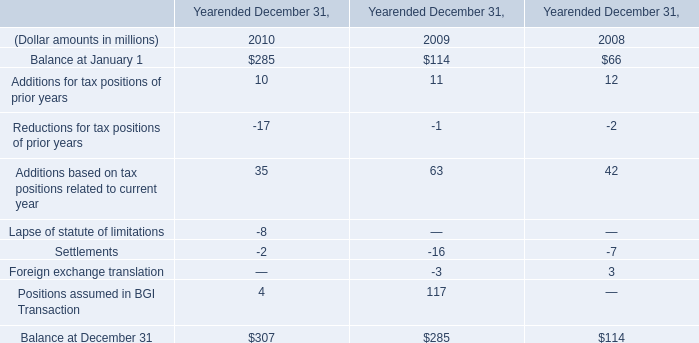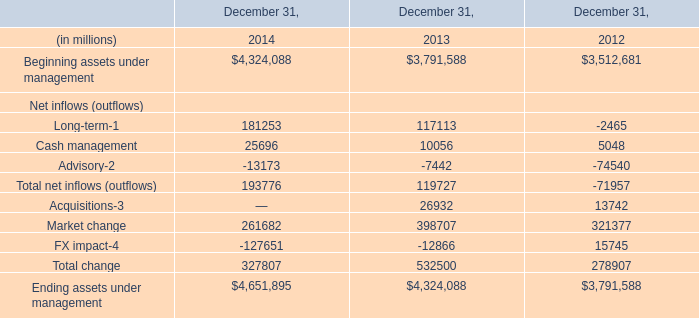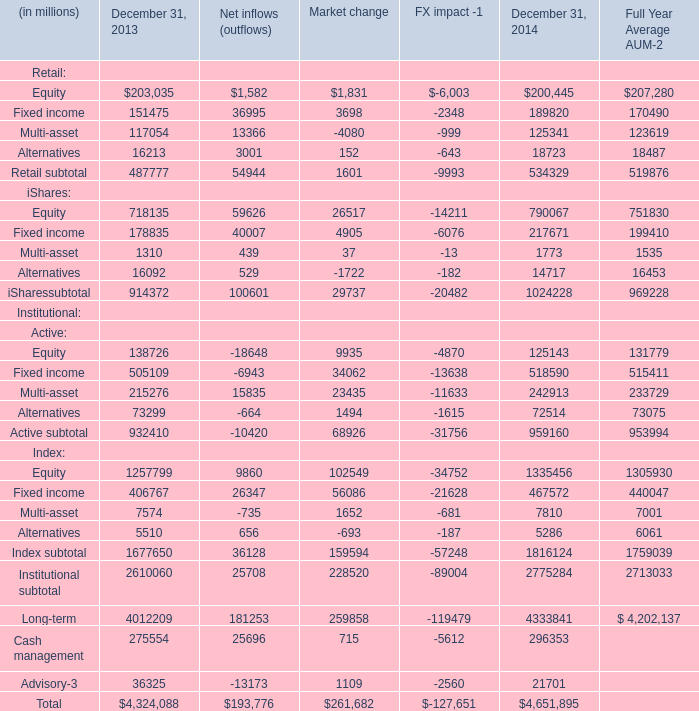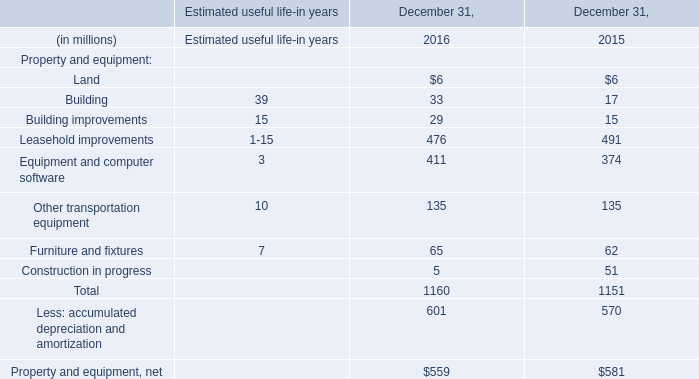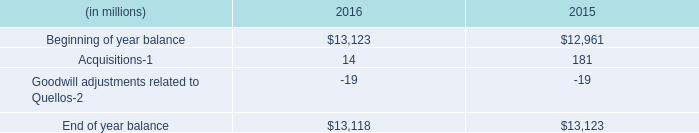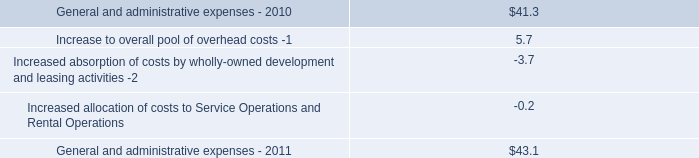What's the average of the Cash management in the years where Acquisitions is positive? (in million) 
Computations: ((10056 + 5048) / 2)
Answer: 7552.0. 